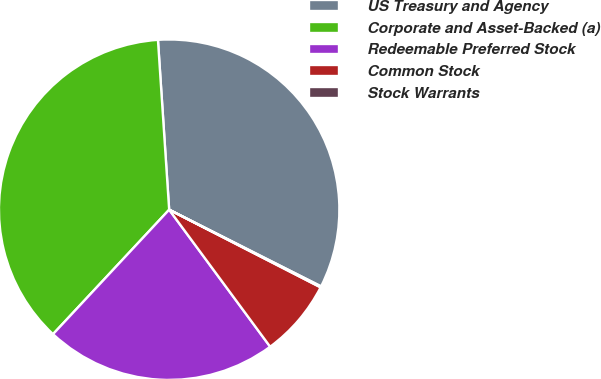Convert chart to OTSL. <chart><loc_0><loc_0><loc_500><loc_500><pie_chart><fcel>US Treasury and Agency<fcel>Corporate and Asset-Backed (a)<fcel>Redeemable Preferred Stock<fcel>Common Stock<fcel>Stock Warrants<nl><fcel>33.49%<fcel>37.0%<fcel>22.06%<fcel>7.35%<fcel>0.1%<nl></chart> 